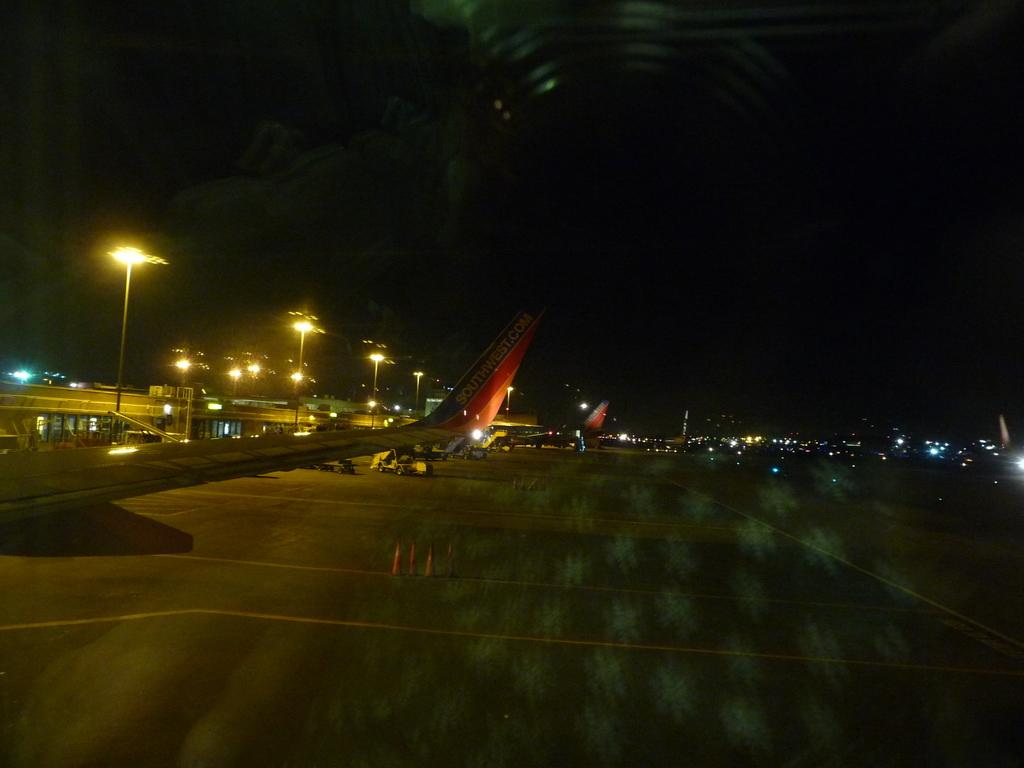What is in the foreground of the image? There is a road in the foreground of the image. What can be seen on the left side of the image? There are airplanes on the left side of the image. What objects are present in the image that support or hold something? There are poles in the image. What objects in the image provide illumination? There are lights in the image. What type of structures are visible in the image? There are buildings in the image. What is the condition of the sky in the image? The sky is dark at the top of the image. Where is the gate located in the image? There is no gate present in the image. Can you tell me how many tomatoes are growing on the poles in the image? There are no tomatoes present in the image; the poles are not associated with any plants or vegetation. 